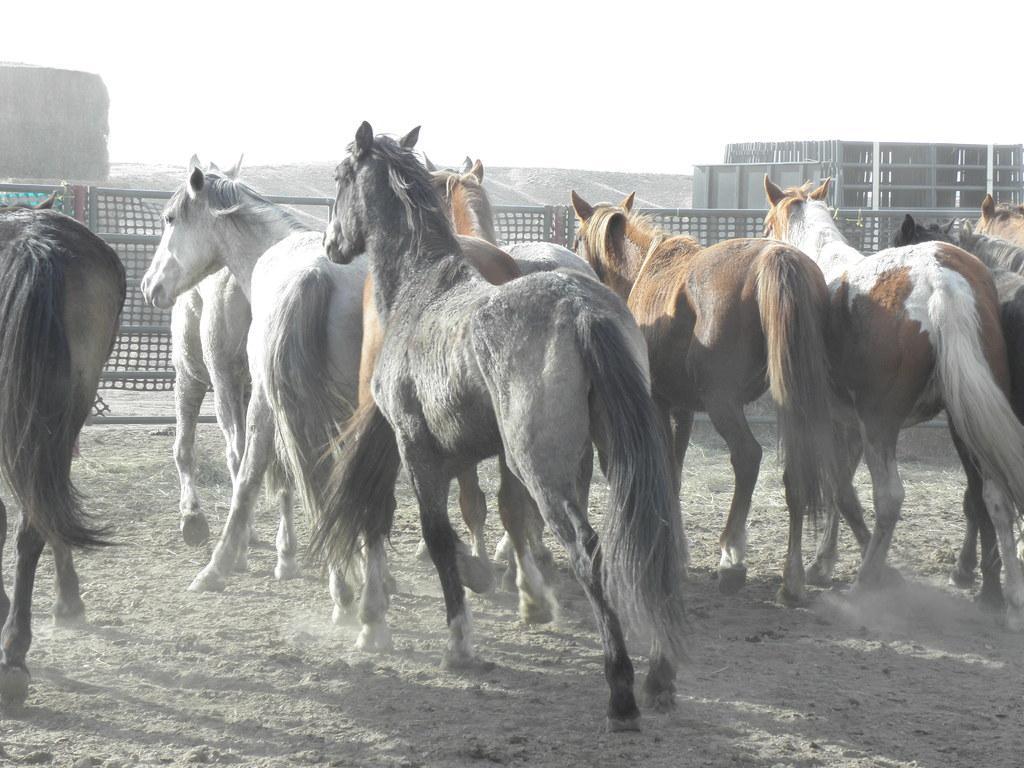Please provide a concise description of this image. In the middle of the image there are many horses with black, white and brown color is running on the ground. In front of them there is a fencing. Behind the fencing to the right side there is a building under construction and also there are hills. And to the top of the image there is a sky. 